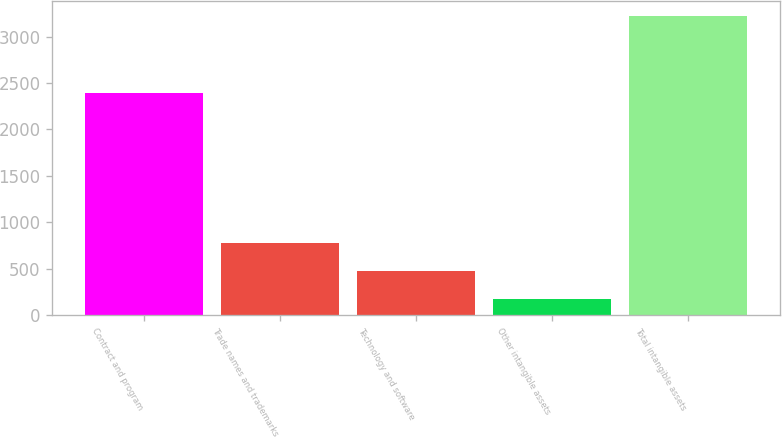Convert chart. <chart><loc_0><loc_0><loc_500><loc_500><bar_chart><fcel>Contract and program<fcel>Trade names and trademarks<fcel>Technology and software<fcel>Other intangible assets<fcel>Total intangible assets<nl><fcel>2393<fcel>783<fcel>478.5<fcel>174<fcel>3219<nl></chart> 